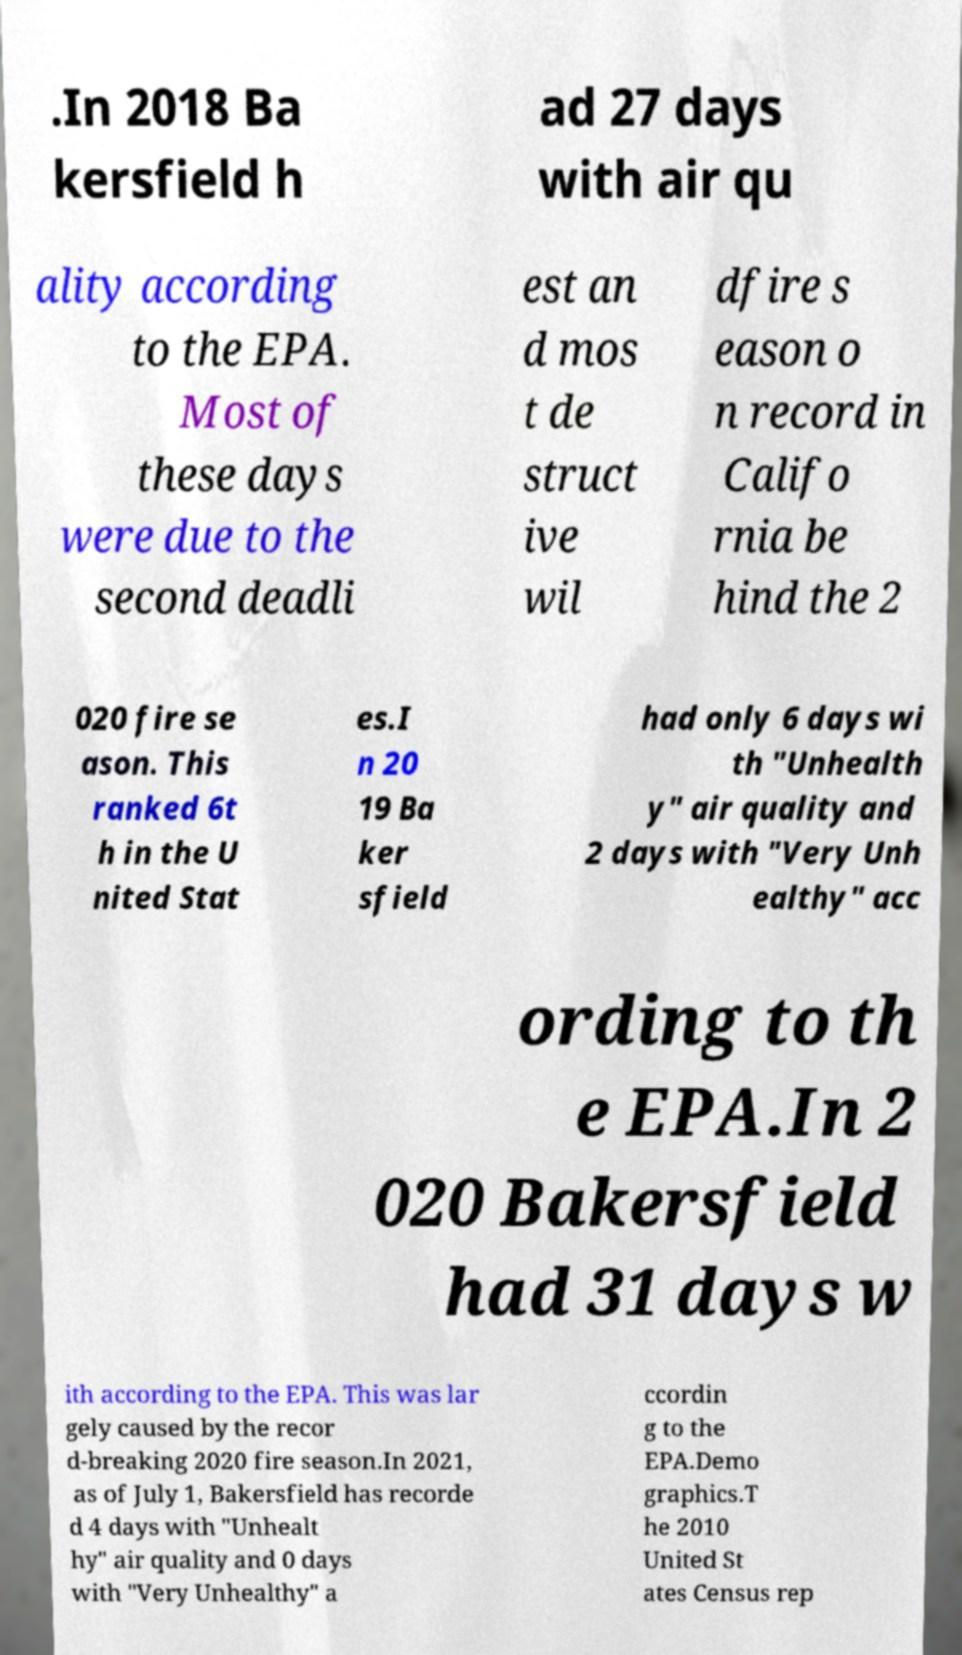Please identify and transcribe the text found in this image. .In 2018 Ba kersfield h ad 27 days with air qu ality according to the EPA. Most of these days were due to the second deadli est an d mos t de struct ive wil dfire s eason o n record in Califo rnia be hind the 2 020 fire se ason. This ranked 6t h in the U nited Stat es.I n 20 19 Ba ker sfield had only 6 days wi th "Unhealth y" air quality and 2 days with "Very Unh ealthy" acc ording to th e EPA.In 2 020 Bakersfield had 31 days w ith according to the EPA. This was lar gely caused by the recor d-breaking 2020 fire season.In 2021, as of July 1, Bakersfield has recorde d 4 days with "Unhealt hy" air quality and 0 days with "Very Unhealthy" a ccordin g to the EPA.Demo graphics.T he 2010 United St ates Census rep 